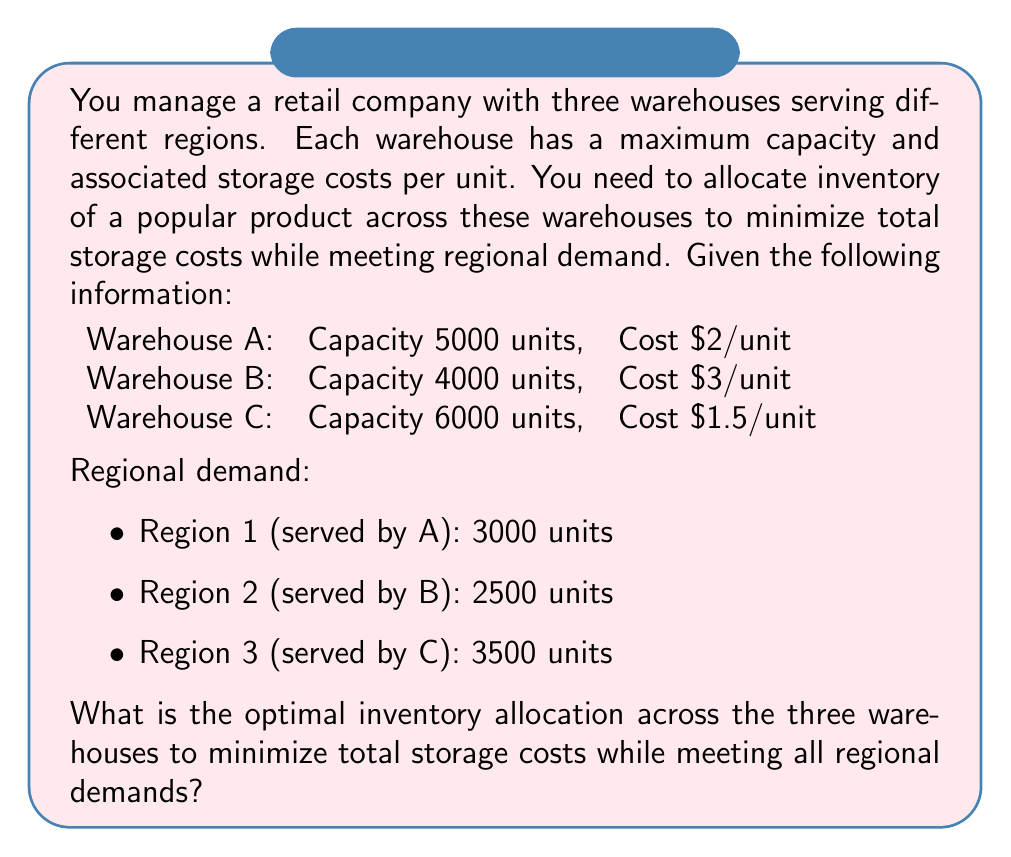Could you help me with this problem? To solve this optimization problem, we'll use the following approach:

1. Set up the objective function to minimize total storage costs.
2. Define the constraints based on warehouse capacities and regional demands.
3. Solve the linear programming problem.

Let $x_A$, $x_B$, and $x_C$ be the number of units allocated to Warehouses A, B, and C, respectively.

Objective function:
Minimize $Z = 2x_A + 3x_B + 1.5x_C$

Constraints:
1. Capacity constraints:
   $x_A \leq 5000$
   $x_B \leq 4000$
   $x_C \leq 6000$

2. Demand constraints:
   $x_A \geq 3000$
   $x_B \geq 2500$
   $x_C \geq 3500$

3. Non-negativity constraints:
   $x_A, x_B, x_C \geq 0$

To minimize costs, we should allocate the minimum required units to the more expensive warehouses (A and B) and use the cheapest warehouse (C) for any excess inventory.

Therefore:
$x_A = 3000$ (meeting Region 1 demand)
$x_B = 2500$ (meeting Region 2 demand)
$x_C = 3500$ (meeting Region 3 demand)

Total units allocated: $3000 + 2500 + 3500 = 9000$

This allocation satisfies all constraints and minimizes the total storage cost.
Answer: The optimal inventory allocation is:
Warehouse A: 3000 units
Warehouse B: 2500 units
Warehouse C: 3500 units

Total storage cost: $2(3000) + 3(2500) + 1.5(3500) = $6000 + $7500 + $5250 = $18,750 